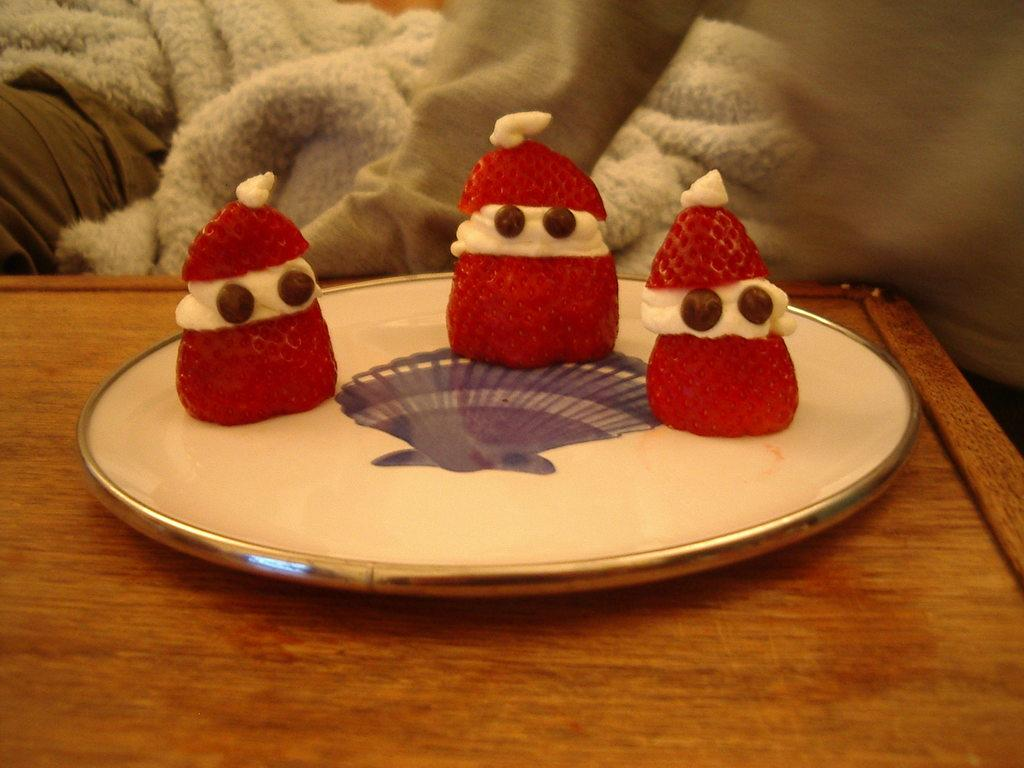What is on the table in the image? There is a plate on a table in the image. What is on the plate? There are three strawberries on the plate. What is between the strawberries? There is cream between the strawberries. What can be seen in the background of the image? In the background, there is a blanket and pillows. What type of stamp can be seen on the canvas in the image? There is no canvas or stamp present in the image. 